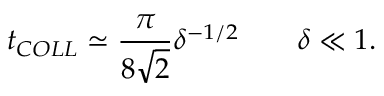Convert formula to latex. <formula><loc_0><loc_0><loc_500><loc_500>t _ { C O L L } \simeq \frac { \pi } { 8 \sqrt { 2 } } \delta ^ { - 1 / 2 } \delta \ll 1 .</formula> 